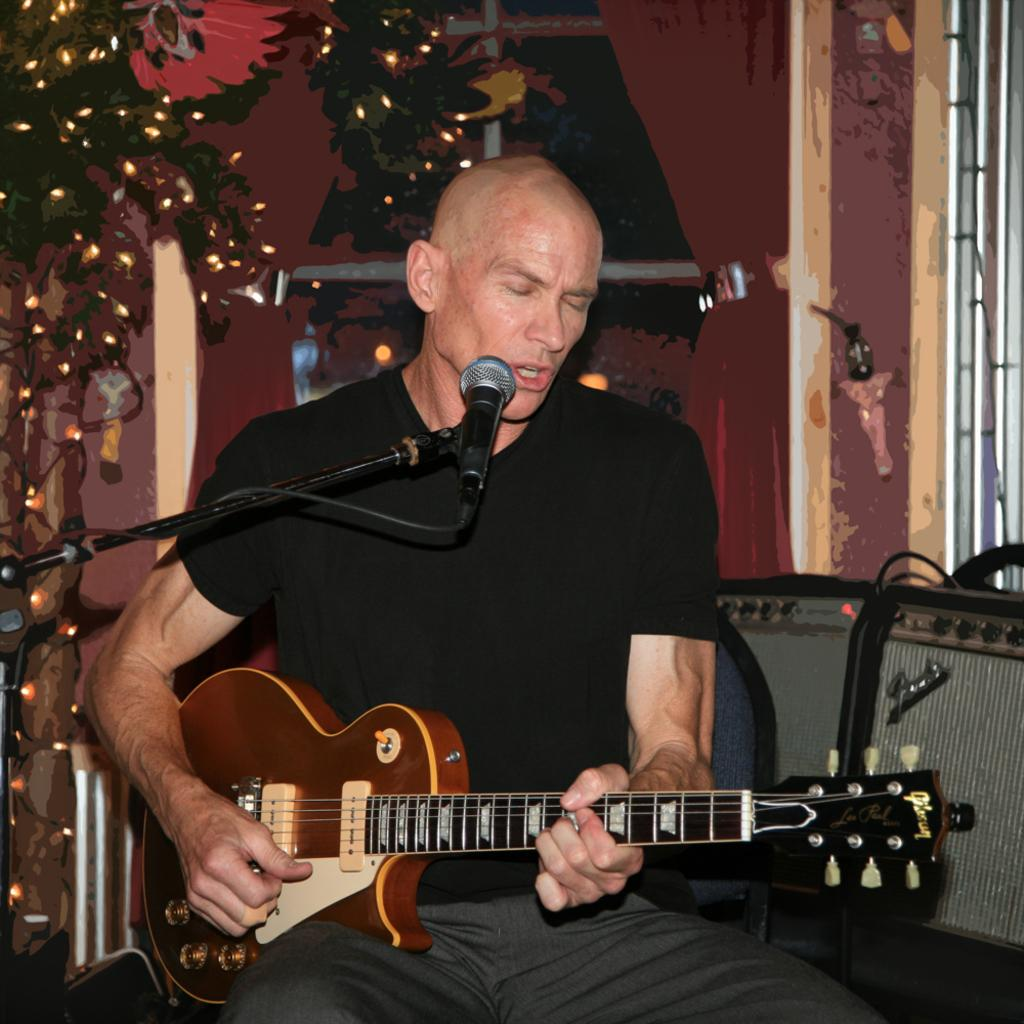What is the man in the image doing? The man is sitting and singing on a microphone. What object is the man holding in his hand? The man is holding a guitar in his hand. What additional object can be seen in the image? There is a Christmas tree in the image. Where is the scarecrow located in the image? There is no scarecrow present in the image. 